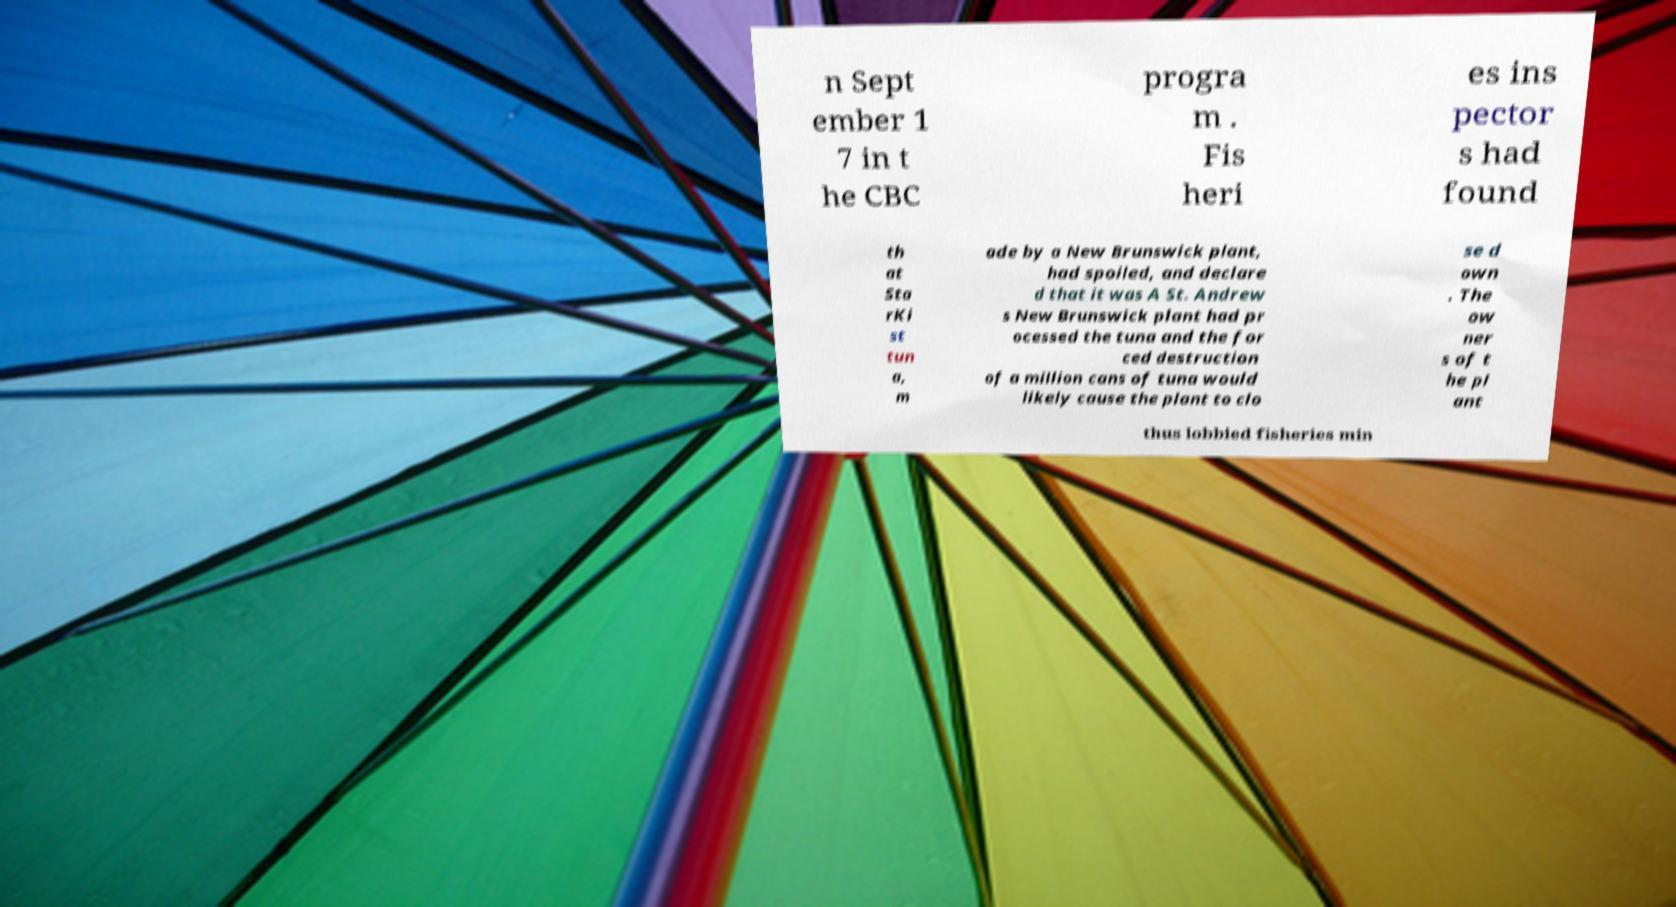Please identify and transcribe the text found in this image. n Sept ember 1 7 in t he CBC progra m . Fis heri es ins pector s had found th at Sta rKi st tun a, m ade by a New Brunswick plant, had spoiled, and declare d that it was A St. Andrew s New Brunswick plant had pr ocessed the tuna and the for ced destruction of a million cans of tuna would likely cause the plant to clo se d own . The ow ner s of t he pl ant thus lobbied fisheries min 